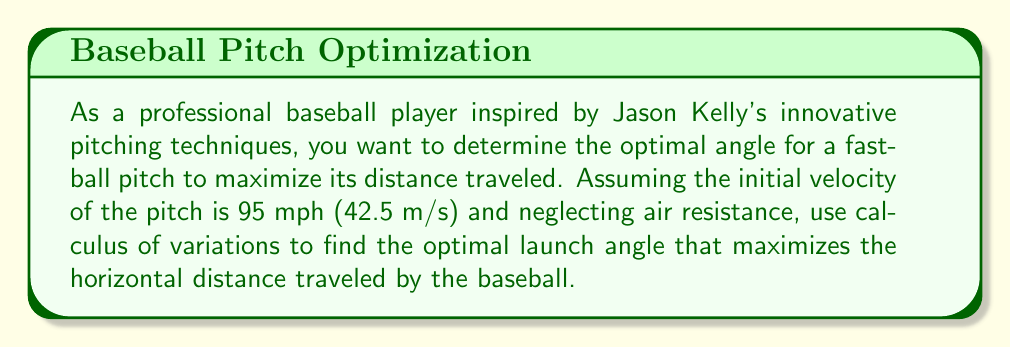Could you help me with this problem? To solve this problem, we'll use the calculus of variations to maximize the horizontal distance traveled by the baseball. Let's approach this step-by-step:

1) The trajectory of the baseball can be described by the equation:

   $$y(x) = x \tan \theta - \frac{gx^2}{2v_0^2 \cos^2 \theta}$$

   Where $y$ is the vertical position, $x$ is the horizontal position, $\theta$ is the launch angle, $g$ is the acceleration due to gravity (9.8 m/s²), and $v_0$ is the initial velocity (42.5 m/s).

2) The baseball reaches the ground when $y(x) = 0$. Solving this equation:

   $$0 = x \tan \theta - \frac{gx^2}{2v_0^2 \cos^2 \theta}$$

3) The non-zero solution for $x$ gives us the horizontal distance traveled:

   $$x = \frac{2v_0^2}{g} \sin \theta \cos \theta = \frac{v_0^2}{g} \sin 2\theta$$

4) To maximize this distance, we need to find the value of $\theta$ that maximizes $\sin 2\theta$. We can do this by differentiating with respect to $\theta$ and setting the result to zero:

   $$\frac{d}{d\theta}(\sin 2\theta) = 2\cos 2\theta = 0$$

5) This equation is satisfied when $2\theta = 90°$ or $\theta = 45°$.

6) The second derivative test confirms that this is indeed a maximum.

7) Therefore, the optimal launch angle to maximize the horizontal distance is 45°.

8) We can calculate the maximum distance by substituting this angle back into our distance equation:

   $$x_{max} = \frac{v_0^2}{g} \sin(2 \cdot 45°) = \frac{v_0^2}{g} = \frac{(42.5 \text{ m/s})^2}{9.8 \text{ m/s}^2} \approx 184.4 \text{ m}$$
Answer: 45° 